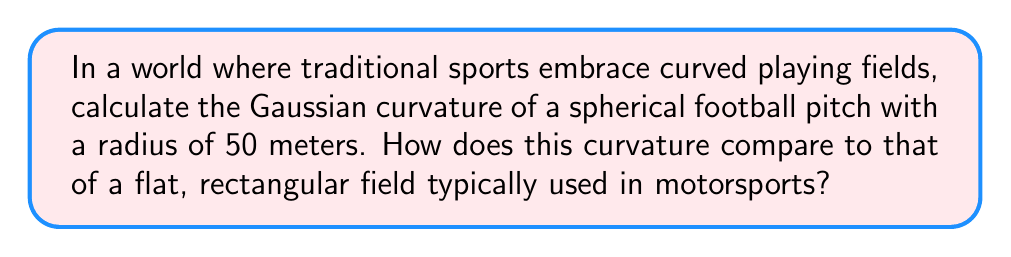Solve this math problem. Let's approach this step-by-step:

1) The Gaussian curvature ($K$) of a sphere is constant over its entire surface and is given by the formula:

   $$K = \frac{1}{R^2}$$

   where $R$ is the radius of the sphere.

2) We are given that the radius of the spherical football pitch is 50 meters. Let's substitute this into our formula:

   $$K = \frac{1}{(50\text{ m})^2} = \frac{1}{2500\text{ m}^2} = 0.0004\text{ m}^{-2}$$

3) To compare this with a flat field, we need to consider that a flat surface has zero Gaussian curvature everywhere. This is because a flat surface can be bent in one direction without stretching or compressing the surface.

4) The Gaussian curvature of a flat rectangular field (as used in motorsports) is:

   $$K_{\text{flat}} = 0\text{ m}^{-2}$$

5) The difference in curvature is thus:

   $$0.0004\text{ m}^{-2} - 0\text{ m}^{-2} = 0.0004\text{ m}^{-2}$$

This positive curvature indicates that the spherical field curves inward in all directions, unlike the flat motorsports field.

[asy]
import geometry;

size(200);
draw(circle((0,0),50), blue);
draw((-50,0)--(50,0), red);
label("Spherical field", (0,30), N, blue);
label("Flat field", (0,-30), S, red);
[/asy]
Answer: $0.0004\text{ m}^{-2}$ 